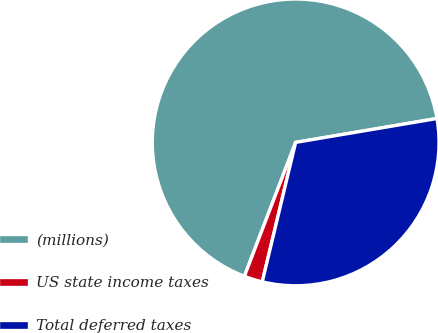Convert chart. <chart><loc_0><loc_0><loc_500><loc_500><pie_chart><fcel>(millions)<fcel>US state income taxes<fcel>Total deferred taxes<nl><fcel>66.51%<fcel>2.08%<fcel>31.4%<nl></chart> 